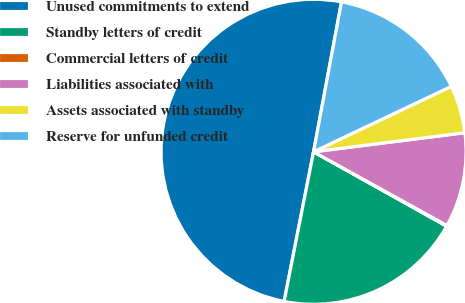Convert chart to OTSL. <chart><loc_0><loc_0><loc_500><loc_500><pie_chart><fcel>Unused commitments to extend<fcel>Standby letters of credit<fcel>Commercial letters of credit<fcel>Liabilities associated with<fcel>Assets associated with standby<fcel>Reserve for unfunded credit<nl><fcel>49.84%<fcel>19.98%<fcel>0.08%<fcel>10.03%<fcel>5.06%<fcel>15.01%<nl></chart> 